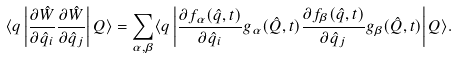<formula> <loc_0><loc_0><loc_500><loc_500>\langle q \left | \frac { \partial \hat { W } } { \partial \hat { q } _ { i } } \frac { \partial \hat { W } } { \partial \hat { q } _ { j } } \right | Q \rangle = \sum _ { { \alpha } , { \beta } } \langle q \left | \frac { \partial f _ { \alpha } ( \hat { q } , t ) } { \partial \hat { q } _ { i } } g _ { \alpha } ( \hat { Q } , t ) \frac { \partial f _ { \beta } ( \hat { q } , t ) } { \partial \hat { q } _ { j } } g _ { \beta } ( \hat { Q } , t ) \right | Q \rangle .</formula> 